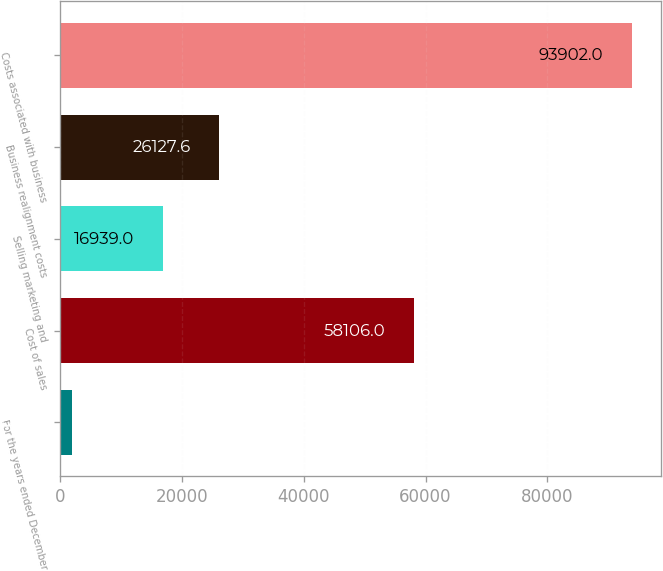Convert chart to OTSL. <chart><loc_0><loc_0><loc_500><loc_500><bar_chart><fcel>For the years ended December<fcel>Cost of sales<fcel>Selling marketing and<fcel>Business realignment costs<fcel>Costs associated with business<nl><fcel>2016<fcel>58106<fcel>16939<fcel>26127.6<fcel>93902<nl></chart> 